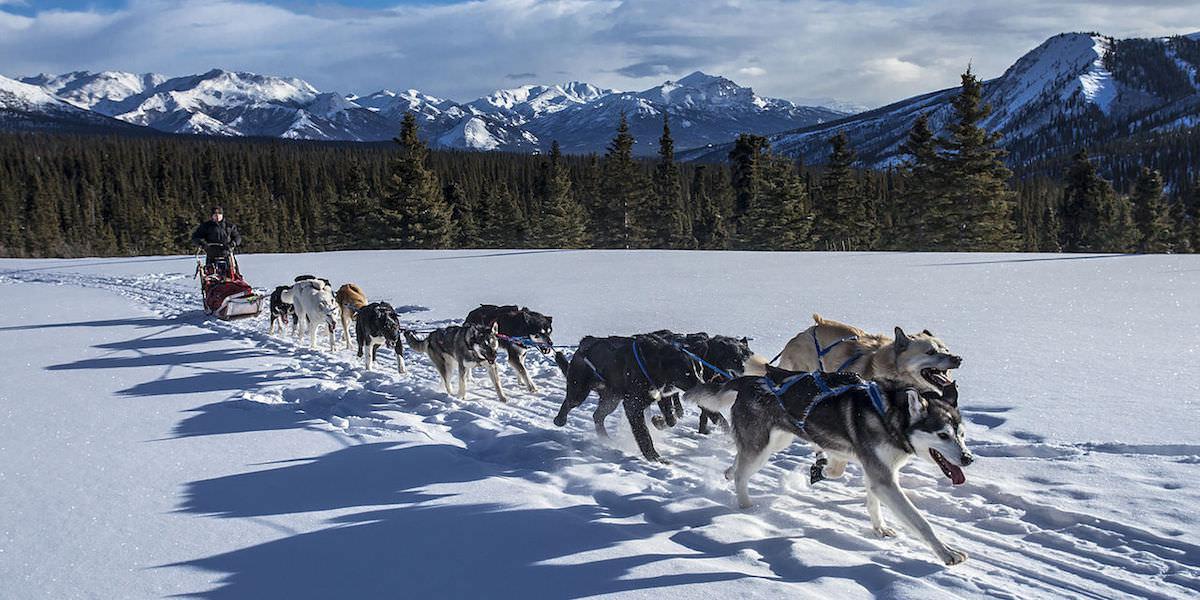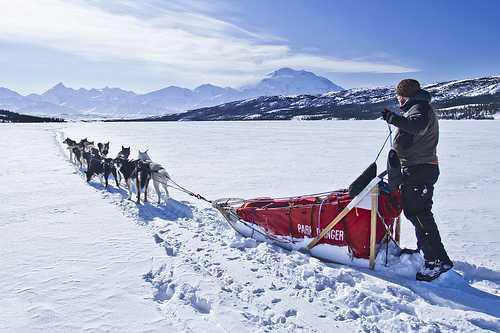The first image is the image on the left, the second image is the image on the right. Assess this claim about the two images: "There is exactly one sled driver visible.". Correct or not? Answer yes or no. No. The first image is the image on the left, the second image is the image on the right. Considering the images on both sides, is "One image shows a sled driver standing on the right, behind a red sled that's in profile, with a team of leftward-aimed dogs hitched to it." valid? Answer yes or no. Yes. 